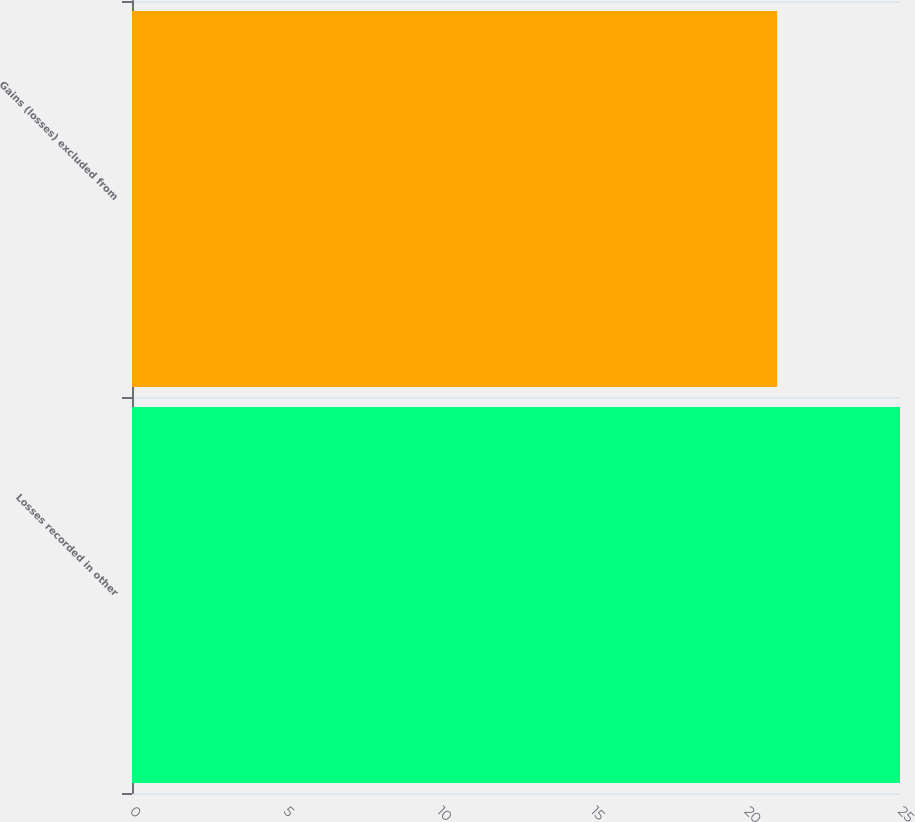Convert chart. <chart><loc_0><loc_0><loc_500><loc_500><bar_chart><fcel>Losses recorded in other<fcel>Gains (losses) excluded from<nl><fcel>25<fcel>21<nl></chart> 